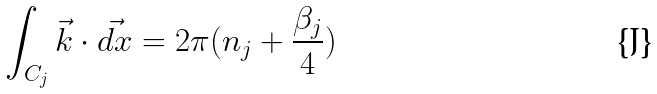Convert formula to latex. <formula><loc_0><loc_0><loc_500><loc_500>\int _ { C _ { j } } \vec { k } \cdot \vec { d x } = 2 \pi ( n _ { j } + \frac { \beta _ { j } } { 4 } )</formula> 